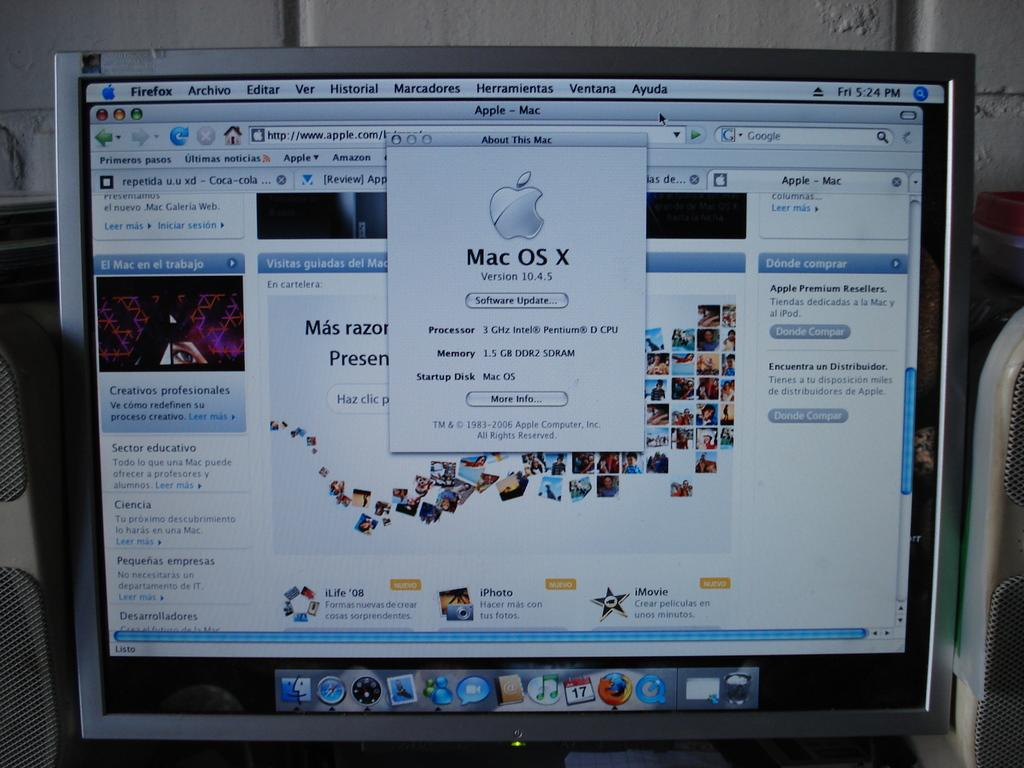<image>
Render a clear and concise summary of the photo. A Mac computer is ready for the Version 10.4.5 software update. 